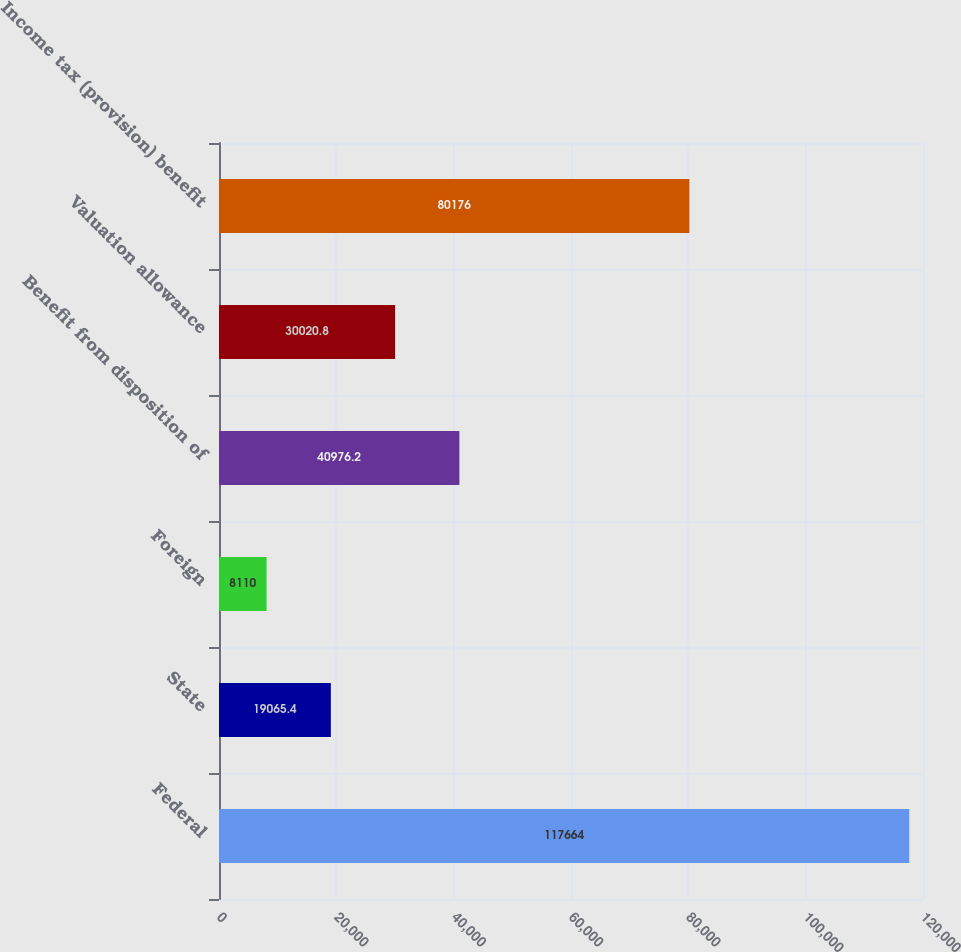<chart> <loc_0><loc_0><loc_500><loc_500><bar_chart><fcel>Federal<fcel>State<fcel>Foreign<fcel>Benefit from disposition of<fcel>Valuation allowance<fcel>Income tax (provision) benefit<nl><fcel>117664<fcel>19065.4<fcel>8110<fcel>40976.2<fcel>30020.8<fcel>80176<nl></chart> 